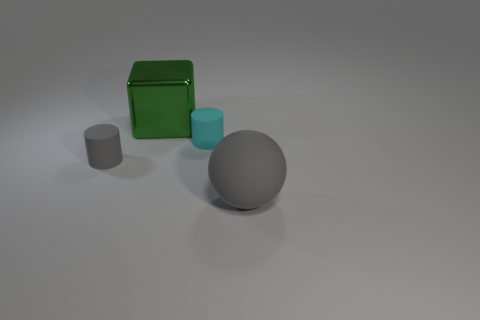Is the number of cyan matte objects to the left of the green thing less than the number of large gray things? Yes, the number of cyan matte objects to the left of the green box, which is one, is indeed less than the number of large gray objects present, which is two. 